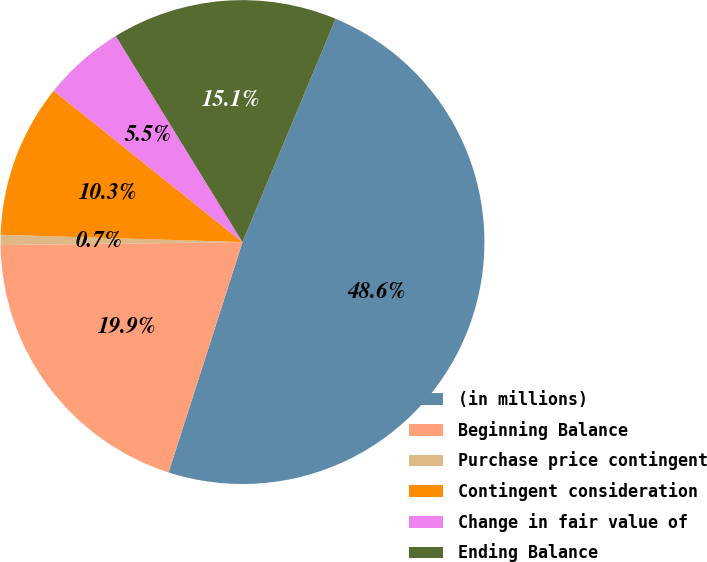Convert chart. <chart><loc_0><loc_0><loc_500><loc_500><pie_chart><fcel>(in millions)<fcel>Beginning Balance<fcel>Purchase price contingent<fcel>Contingent consideration<fcel>Change in fair value of<fcel>Ending Balance<nl><fcel>48.65%<fcel>19.86%<fcel>0.68%<fcel>10.27%<fcel>5.47%<fcel>15.07%<nl></chart> 